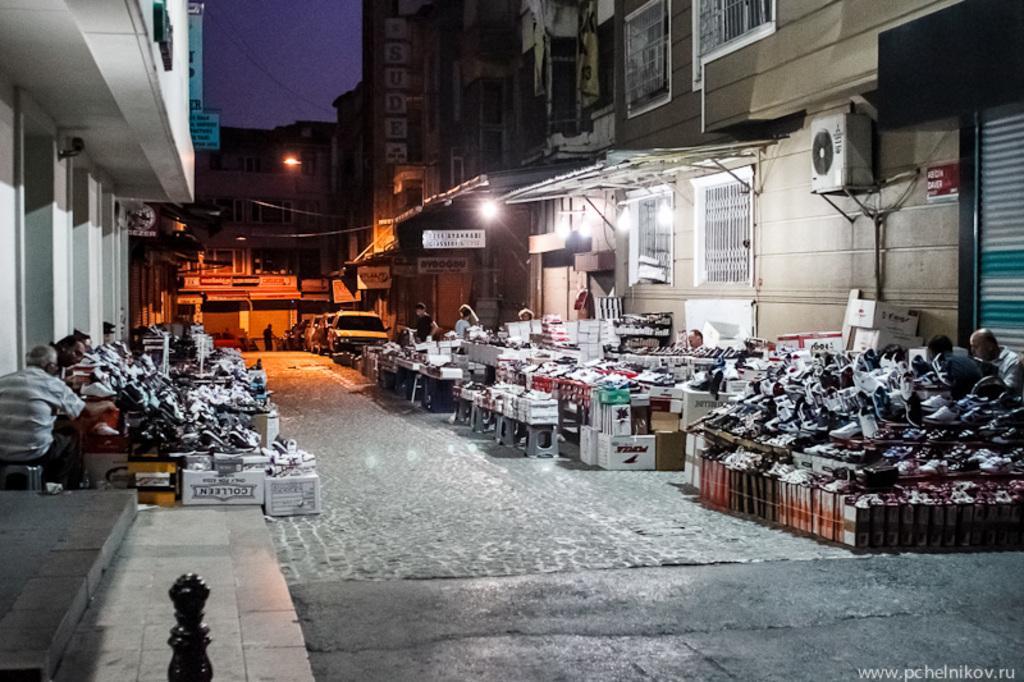Please provide a concise description of this image. This picture shows few buildings and we see open footwear stores on the side and we see people seated and few are standing and few cars parked. 